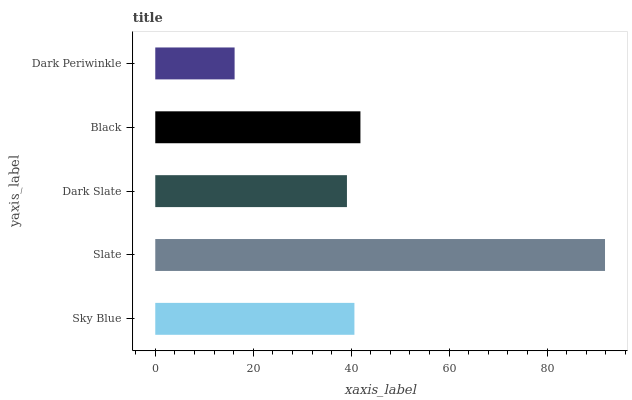Is Dark Periwinkle the minimum?
Answer yes or no. Yes. Is Slate the maximum?
Answer yes or no. Yes. Is Dark Slate the minimum?
Answer yes or no. No. Is Dark Slate the maximum?
Answer yes or no. No. Is Slate greater than Dark Slate?
Answer yes or no. Yes. Is Dark Slate less than Slate?
Answer yes or no. Yes. Is Dark Slate greater than Slate?
Answer yes or no. No. Is Slate less than Dark Slate?
Answer yes or no. No. Is Sky Blue the high median?
Answer yes or no. Yes. Is Sky Blue the low median?
Answer yes or no. Yes. Is Slate the high median?
Answer yes or no. No. Is Dark Periwinkle the low median?
Answer yes or no. No. 